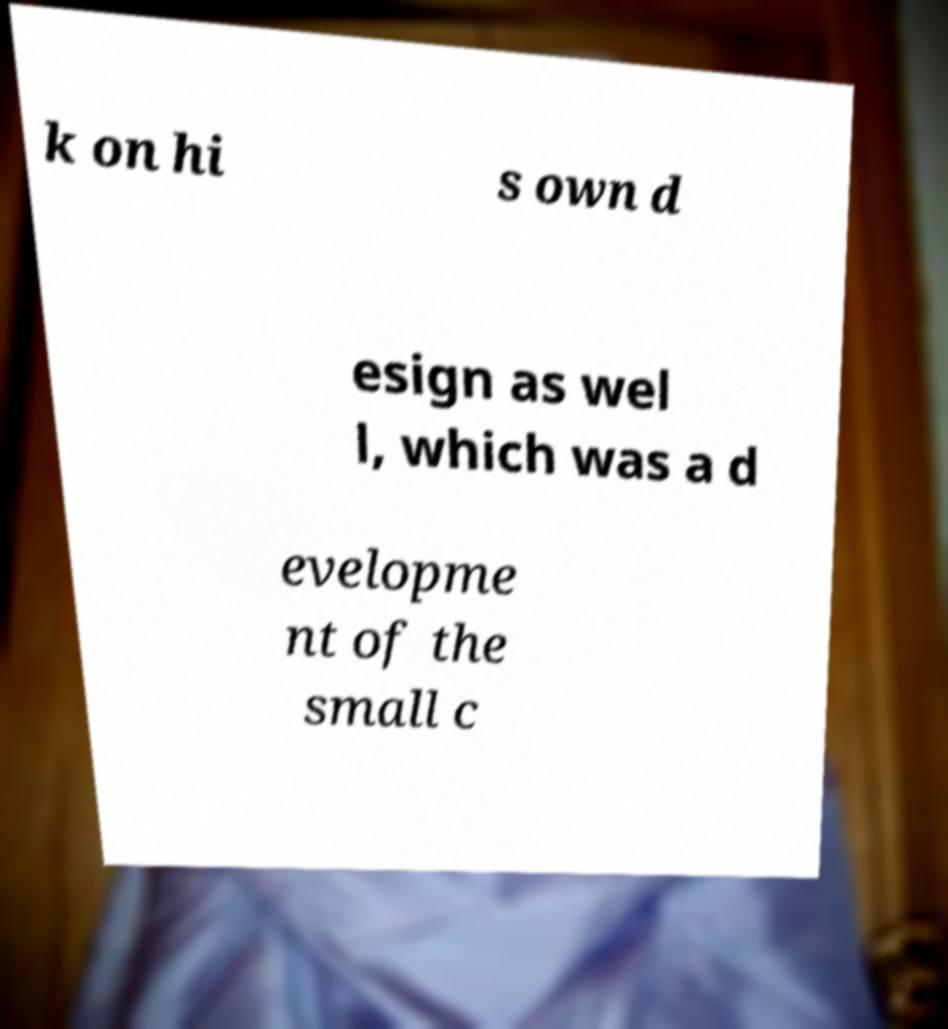Can you accurately transcribe the text from the provided image for me? k on hi s own d esign as wel l, which was a d evelopme nt of the small c 